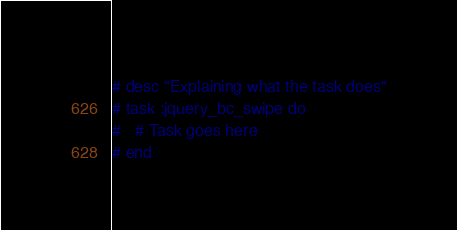Convert code to text. <code><loc_0><loc_0><loc_500><loc_500><_Ruby_># desc "Explaining what the task does"
# task :jquery_bc_swipe do
#   # Task goes here
# end
</code> 